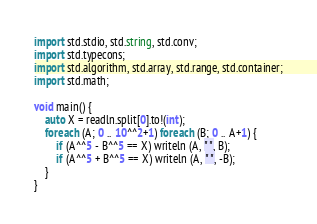Convert code to text. <code><loc_0><loc_0><loc_500><loc_500><_D_>import std.stdio, std.string, std.conv;
import std.typecons;
import std.algorithm, std.array, std.range, std.container;
import std.math;

void main() {
    auto X = readln.split[0].to!(int);
    foreach (A; 0 .. 10^^2+1) foreach (B; 0 .. A+1) {
        if (A^^5 - B^^5 == X) writeln (A, " ", B);
        if (A^^5 + B^^5 == X) writeln (A, " ", -B);
    }
}

</code> 